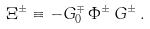<formula> <loc_0><loc_0><loc_500><loc_500>\Xi ^ { \pm } \equiv - G _ { 0 } ^ { \mp } \, \Phi ^ { \pm } \, G ^ { \pm } \, .</formula> 